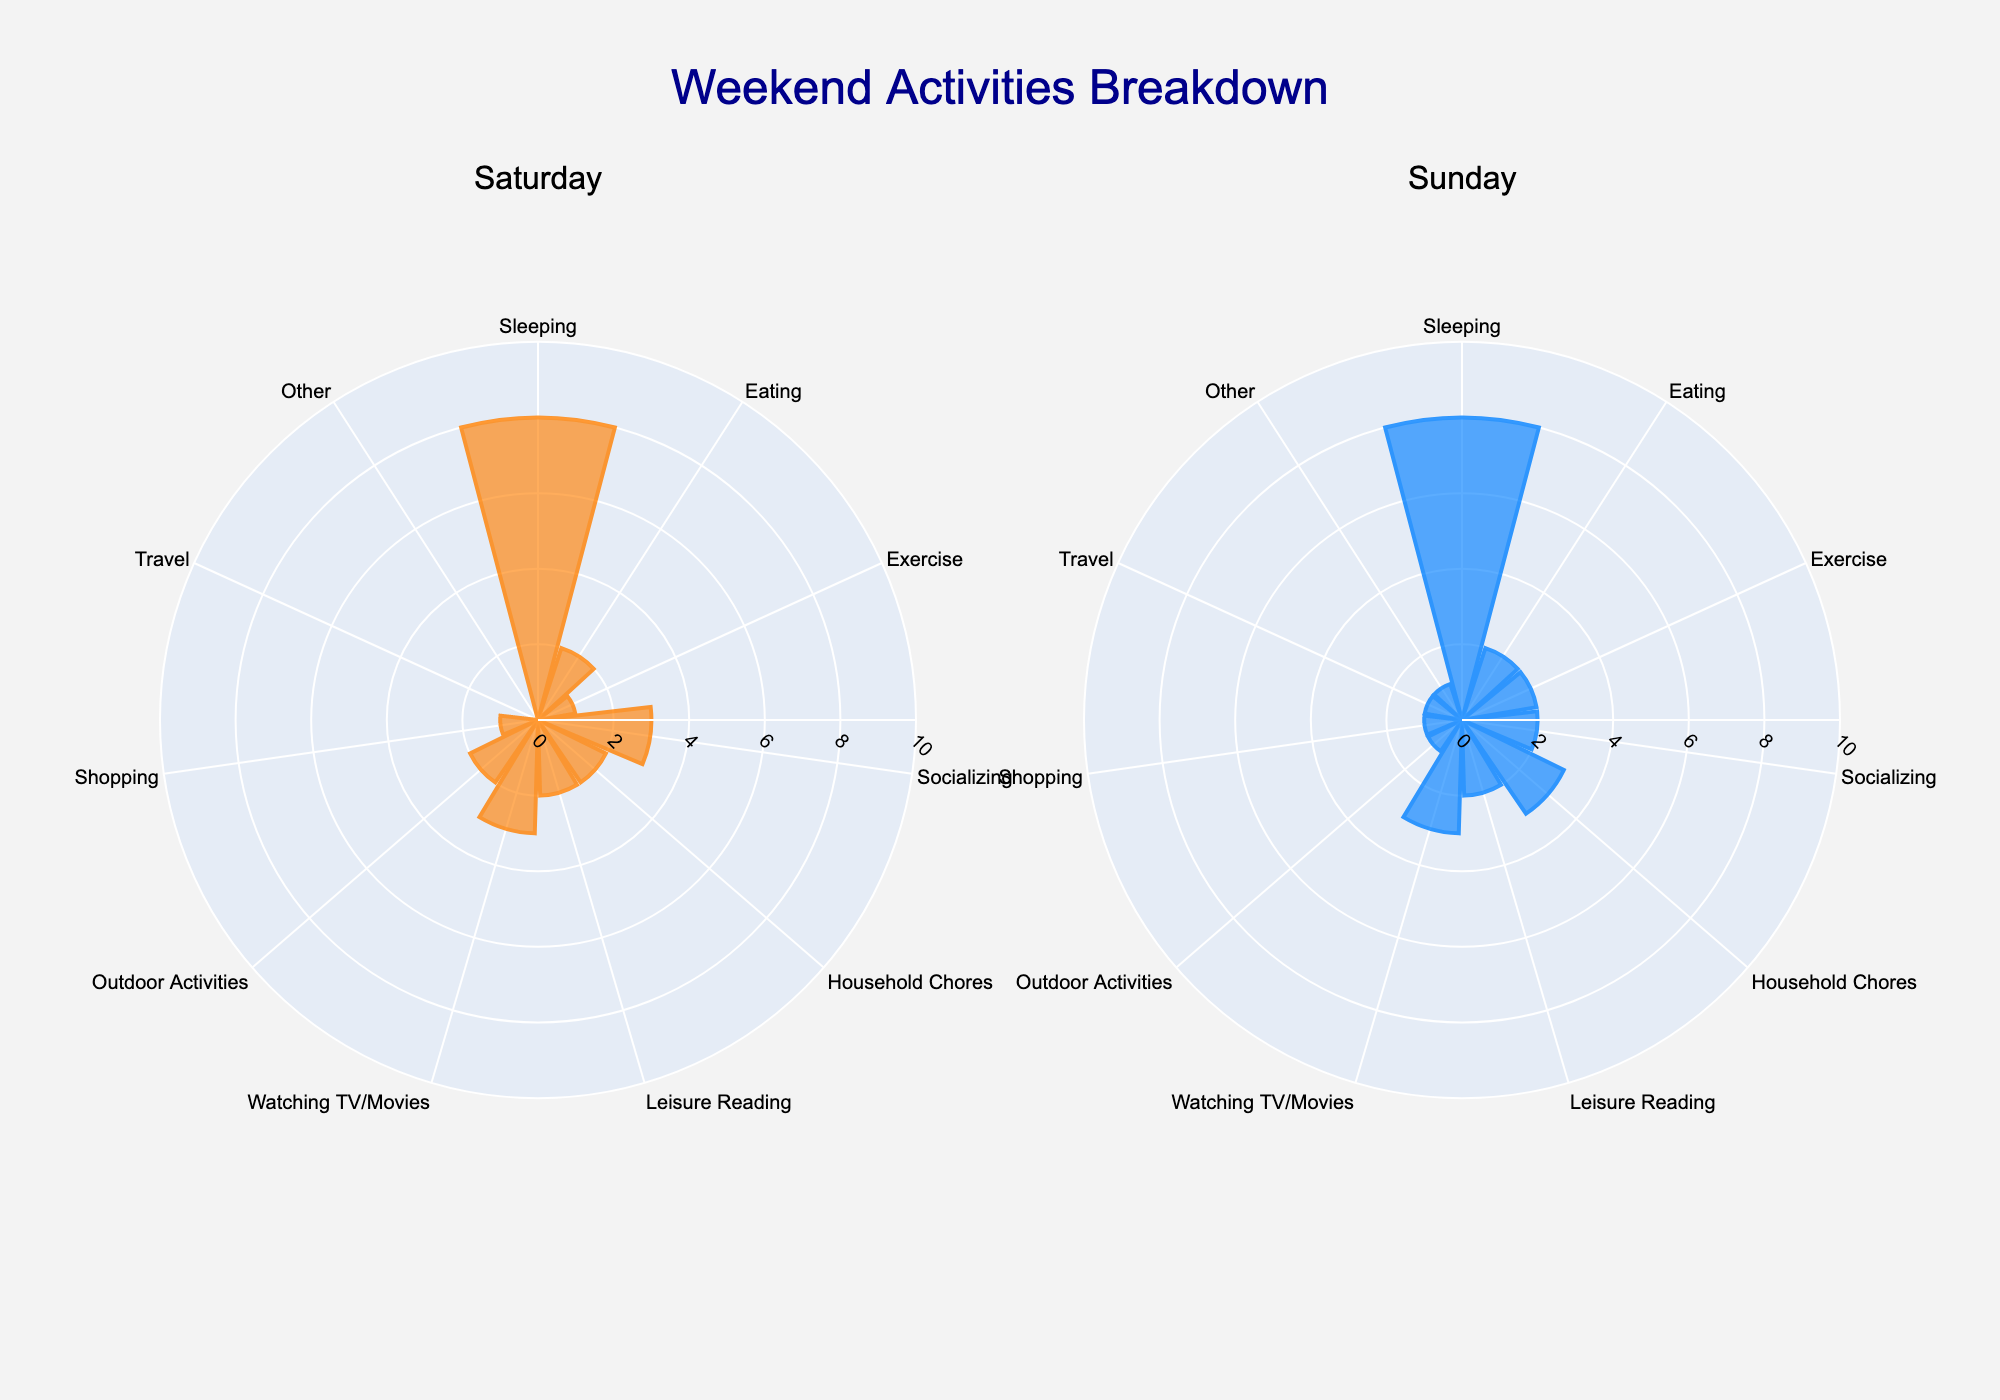What's the title of the figure? The title of the figure is displayed prominently at the top center of the chart, reading, "Weekend Activities Breakdown".
Answer: Weekend Activities Breakdown How many hours are spent on eating on Saturday? Looking at the "Saturday" subplot, we can see the bar for "Eating" is highlighted at the value of 2 hours.
Answer: 2 Which activity has the maximum hours allocated on Sunday? By comparing the lengths of the bars in the "Sunday" subplot, we can see that "Sleeping" has the highest value at 8 hours.
Answer: Sleeping How do the hours spent on exercising differ between Saturday and Sunday? The "Saturday" subplot has 1 hour marked for "Exercise", while the "Sunday" subplot shows 2 hours. The difference is calculated as 2 - 1 = 1 hour.
Answer: 1 hour What's the total number of hours spent on socializing over the weekend? Adding the hours from both subplots: Saturday has 3 hours and Sunday has 2 hours. Total is 3 + 2 = 5 hours.
Answer: 5 hours Which activities are consistently allocated the same hours on both days? By examining the lengths of bars in both subplots, "Sleeping", "Eating", "Leisure Reading", "Watching TV/Movies", "Shopping" have the same hours each day.
Answer: Sleeping, Eating, Leisure Reading, Watching TV/Movies, Shopping Is there any activity performed on Sunday but not on Saturday? The "Sunday" subplot shows 1 hour each for "Travel" and "Other", activities which are absent on Saturday.
Answer: Travel, Other How does the time spent on socializing compare between the two days? The "Saturday" subplot shows 3 hours for "Socializing", while the "Sunday" subplot shows 2 hours. Thus, Saturday has 1 hour more.
Answer: 1 hour more on Saturday What's the average number of hours spent on all activities on Sunday? Summing up the hours for all activities on Sunday: 8 + 2 + 2 + 2 + 3 + 2 + 3 + 1 + 1 + 1 + 1 = 26. The average is 26 hours / 11 activities = 2.36 hours (rounded to two decimal places).
Answer: 2.36 hours Which day has more hours spent on household chores, and by how much? Comparing the "Household Chores" bars, Saturday has 2 hours and Sunday has 3 hours; the difference is 3 - 2 = 1 hour more on Sunday.
Answer: Sunday by 1 hour 